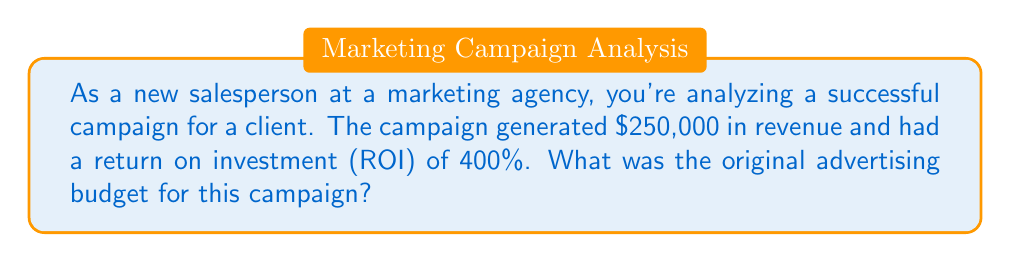What is the answer to this math problem? Let's approach this step-by-step:

1) First, let's recall the formula for ROI:
   $$ ROI = \frac{\text{Gain from Investment} - \text{Cost of Investment}}{\text{Cost of Investment}} \times 100\% $$

2) We know that:
   - Revenue (Gain from Investment) = $250,000
   - ROI = 400% = 4 (as a decimal)
   - We need to find the Cost of Investment (original advertising budget)

3) Let's call the original advertising budget $x$. We can now set up our equation:
   $$ 4 = \frac{250,000 - x}{x} $$

4) Multiply both sides by $x$:
   $$ 4x = 250,000 - x $$

5) Add $x$ to both sides:
   $$ 5x = 250,000 $$

6) Divide both sides by 5:
   $$ x = 50,000 $$

Therefore, the original advertising budget was $50,000.

To verify:
$$ ROI = \frac{250,000 - 50,000}{50,000} \times 100\% = \frac{200,000}{50,000} \times 100\% = 4 \times 100\% = 400\% $$
Answer: $50,000 